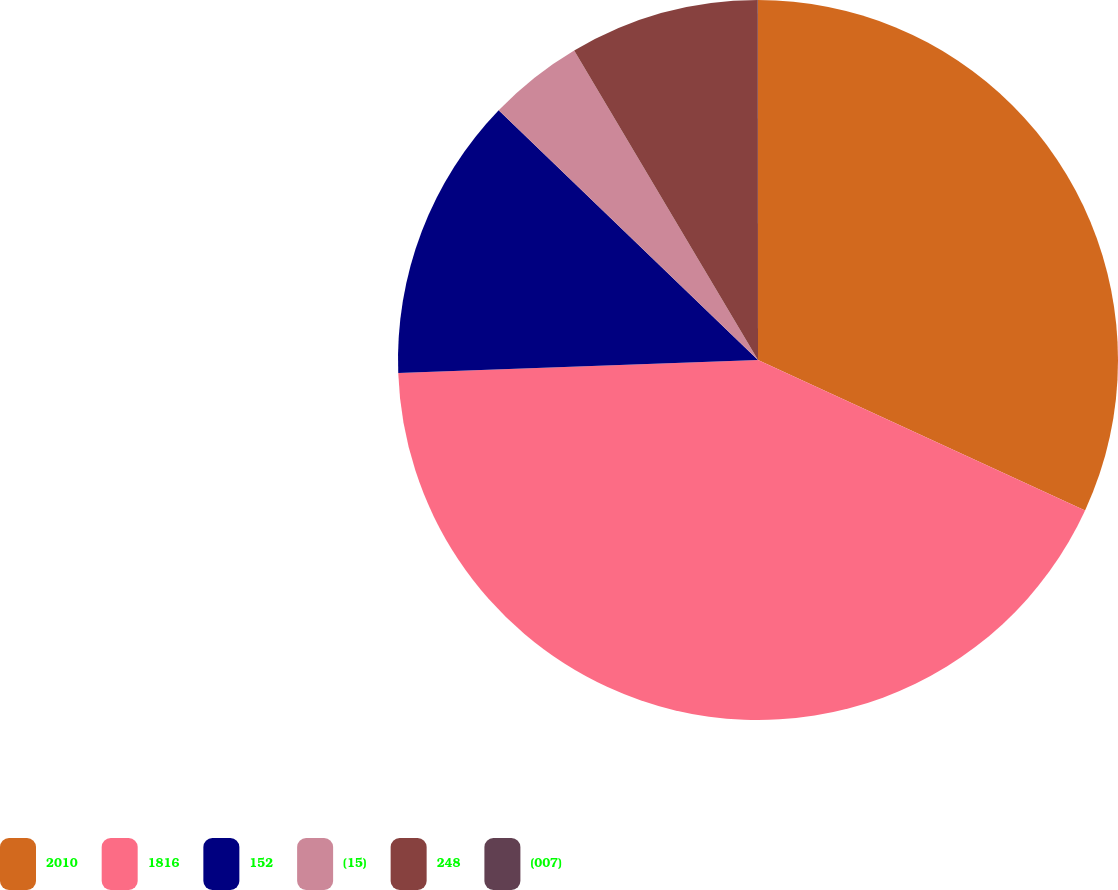Convert chart. <chart><loc_0><loc_0><loc_500><loc_500><pie_chart><fcel>2010<fcel>1816<fcel>152<fcel>(15)<fcel>248<fcel>(007)<nl><fcel>31.86%<fcel>42.56%<fcel>12.78%<fcel>4.27%<fcel>8.52%<fcel>0.01%<nl></chart> 